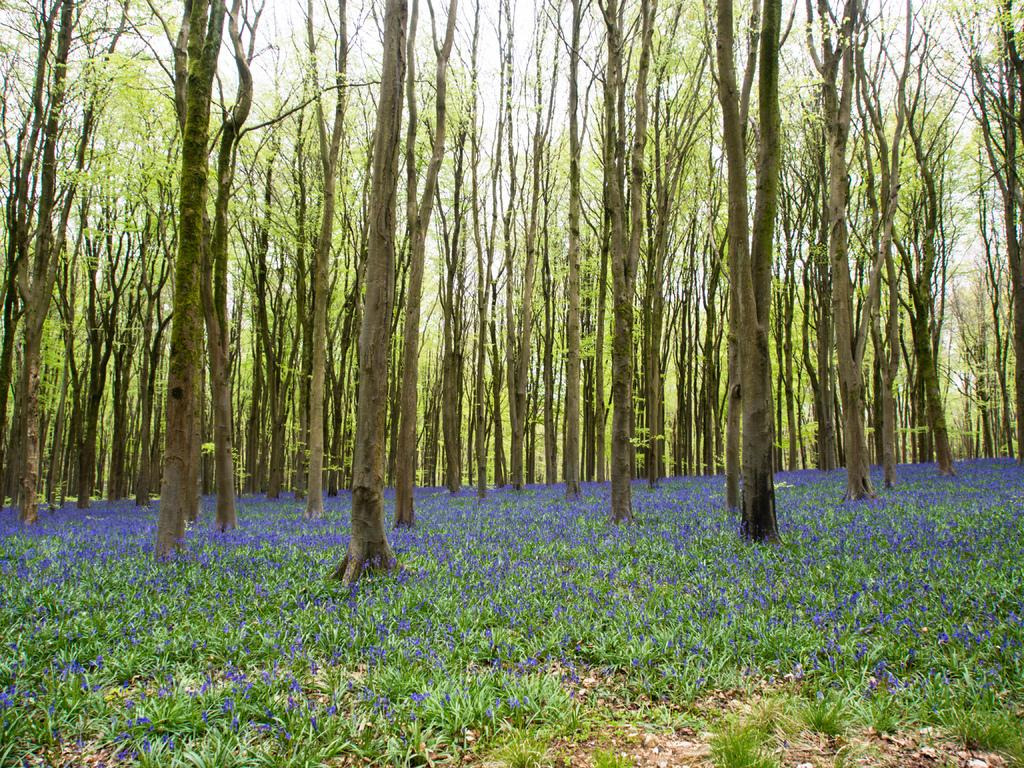What type of vegetation is present in the image? There are trees in the image. What is covering the ground in the image? There is grass on the ground in the image. What color are the flowers in the image? The flowers in the image are blue. What can be seen above the trees and grass in the image? The sky is visible in the image. What is the condition of the sky in the image? The sky appears to be cloudy in the image. How many cats are playing with the bubble in the image? There are no cats or bubbles present in the image. What type of tool is the carpenter using in the image? There is no carpenter or tool present in the image. 